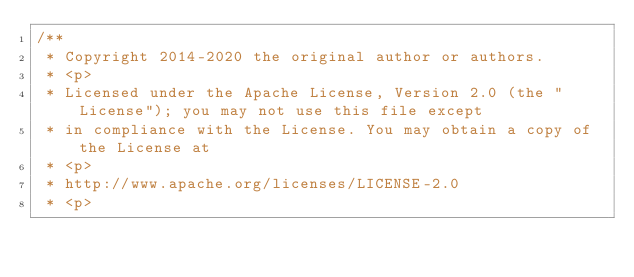Convert code to text. <code><loc_0><loc_0><loc_500><loc_500><_Java_>/**
 * Copyright 2014-2020 the original author or authors.
 * <p>
 * Licensed under the Apache License, Version 2.0 (the "License"); you may not use this file except
 * in compliance with the License. You may obtain a copy of the License at
 * <p>
 * http://www.apache.org/licenses/LICENSE-2.0
 * <p></code> 